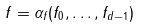Convert formula to latex. <formula><loc_0><loc_0><loc_500><loc_500>f = \alpha _ { f } ( f _ { 0 } , \dots , f _ { d - 1 } )</formula> 